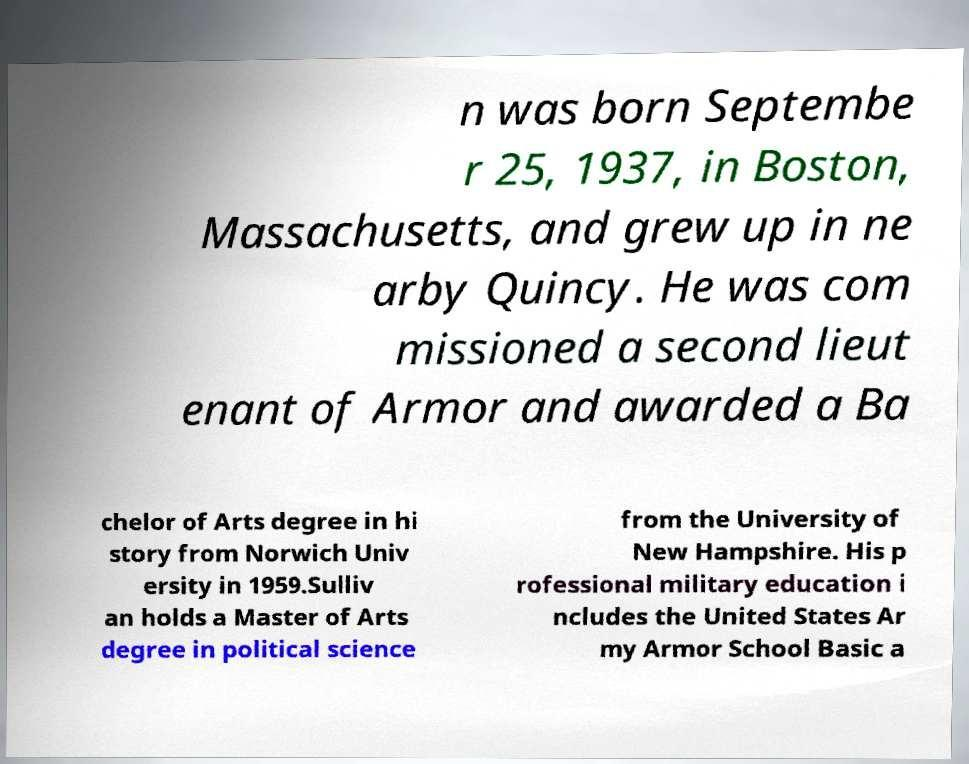Can you read and provide the text displayed in the image?This photo seems to have some interesting text. Can you extract and type it out for me? n was born Septembe r 25, 1937, in Boston, Massachusetts, and grew up in ne arby Quincy. He was com missioned a second lieut enant of Armor and awarded a Ba chelor of Arts degree in hi story from Norwich Univ ersity in 1959.Sulliv an holds a Master of Arts degree in political science from the University of New Hampshire. His p rofessional military education i ncludes the United States Ar my Armor School Basic a 